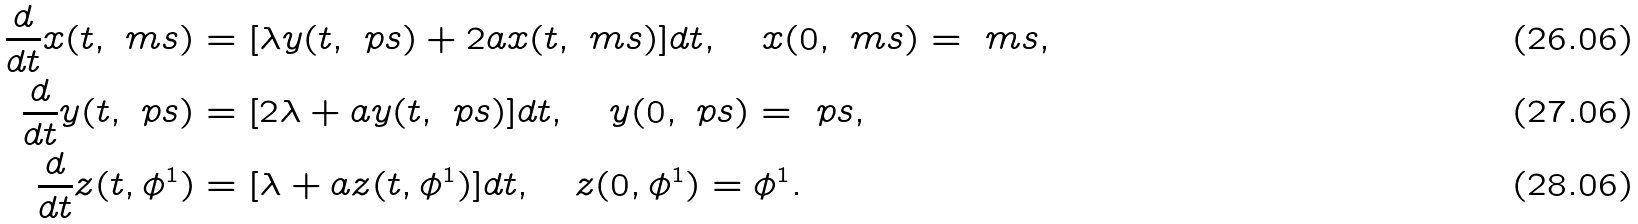<formula> <loc_0><loc_0><loc_500><loc_500>\frac { d } { d t } x ( t , \ m s ) & = [ \lambda y ( t , \ p s ) + 2 a x ( t , \ m s ) ] d t , \quad x ( 0 , \ m s ) = \ m s , \\ \frac { d } { d t } y ( t , \ p s ) & = [ 2 \lambda + a y ( t , \ p s ) ] d t , \quad y ( 0 , \ p s ) = \ p s , \\ \frac { d } { d t } z ( t , \phi ^ { 1 } ) & = [ \lambda + a z ( t , \phi ^ { 1 } ) ] d t , \quad z ( 0 , \phi ^ { 1 } ) = \phi ^ { 1 } .</formula> 